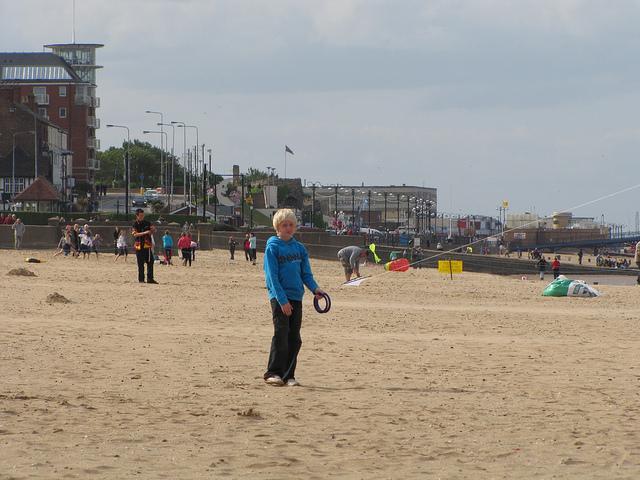What game are the kids playing?
Answer briefly. Kite flying. Are the two people in the foreground standing?
Concise answer only. Yes. Is this a bus station?
Be succinct. No. What is the color of the umbrella?
Short answer required. Brown. What pattern is on the person in the foregrounds blue shirt?
Give a very brief answer. Stripe. How many people are in the picture?
Write a very short answer. 30. What is the man doing?
Concise answer only. Flying kite. What sport is being played?
Keep it brief. Kite flying. How many bins are in there?
Short answer required. 0. Is it windy?
Quick response, please. Yes. Is it cold outside in the photo?
Concise answer only. No. How many people are there?
Answer briefly. 9. What is he playing with?
Give a very brief answer. Kite. 